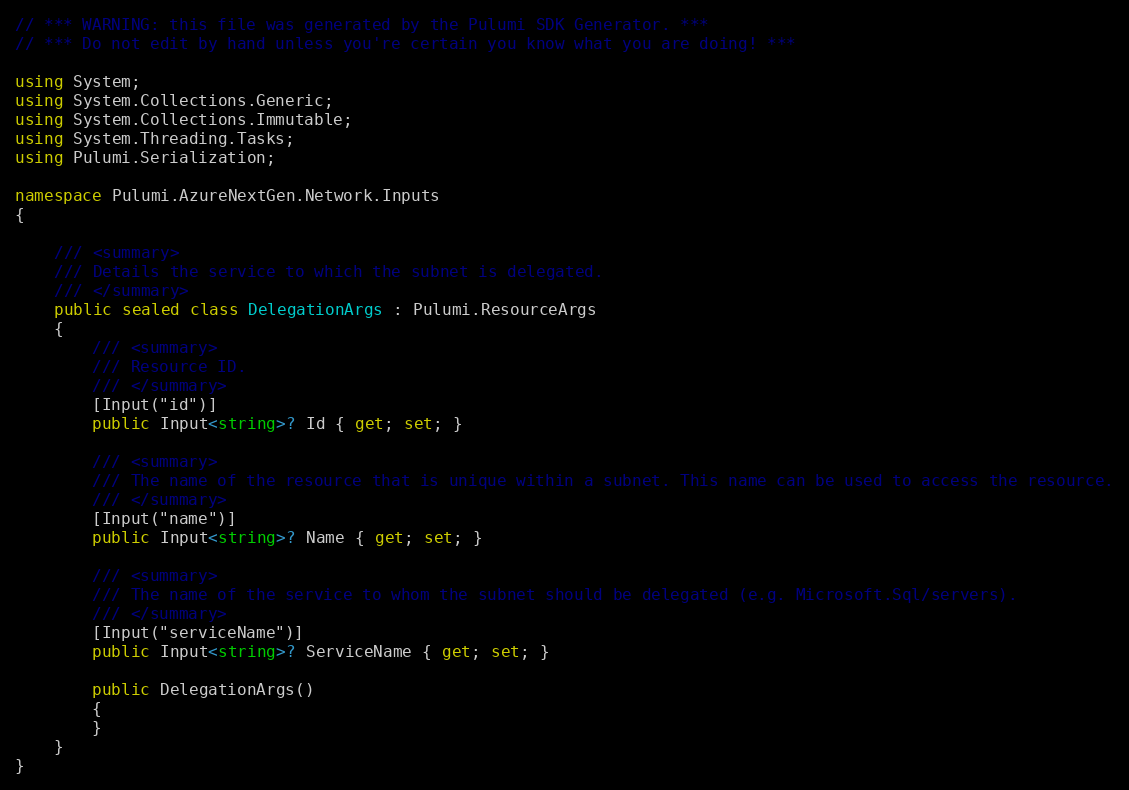<code> <loc_0><loc_0><loc_500><loc_500><_C#_>// *** WARNING: this file was generated by the Pulumi SDK Generator. ***
// *** Do not edit by hand unless you're certain you know what you are doing! ***

using System;
using System.Collections.Generic;
using System.Collections.Immutable;
using System.Threading.Tasks;
using Pulumi.Serialization;

namespace Pulumi.AzureNextGen.Network.Inputs
{

    /// <summary>
    /// Details the service to which the subnet is delegated.
    /// </summary>
    public sealed class DelegationArgs : Pulumi.ResourceArgs
    {
        /// <summary>
        /// Resource ID.
        /// </summary>
        [Input("id")]
        public Input<string>? Id { get; set; }

        /// <summary>
        /// The name of the resource that is unique within a subnet. This name can be used to access the resource.
        /// </summary>
        [Input("name")]
        public Input<string>? Name { get; set; }

        /// <summary>
        /// The name of the service to whom the subnet should be delegated (e.g. Microsoft.Sql/servers).
        /// </summary>
        [Input("serviceName")]
        public Input<string>? ServiceName { get; set; }

        public DelegationArgs()
        {
        }
    }
}
</code> 